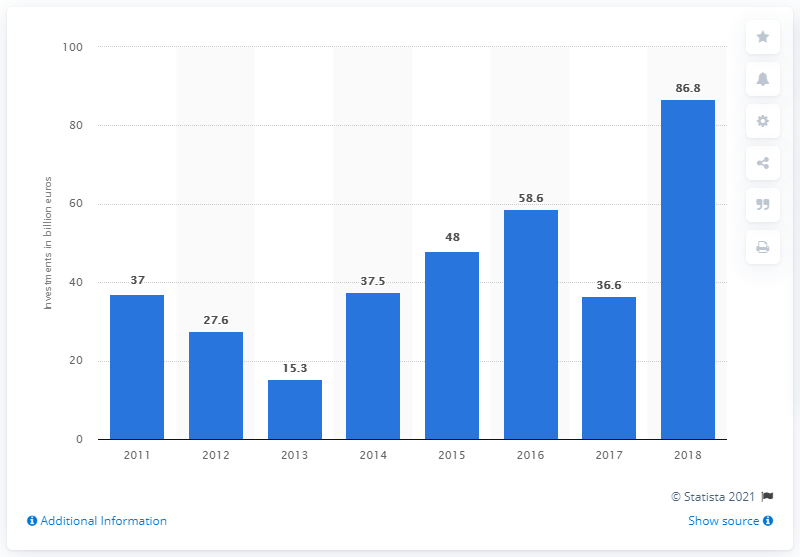Indicate a few pertinent items in this graphic. The amount of foreign direct investment outflow in France fluctuated in 2017. 